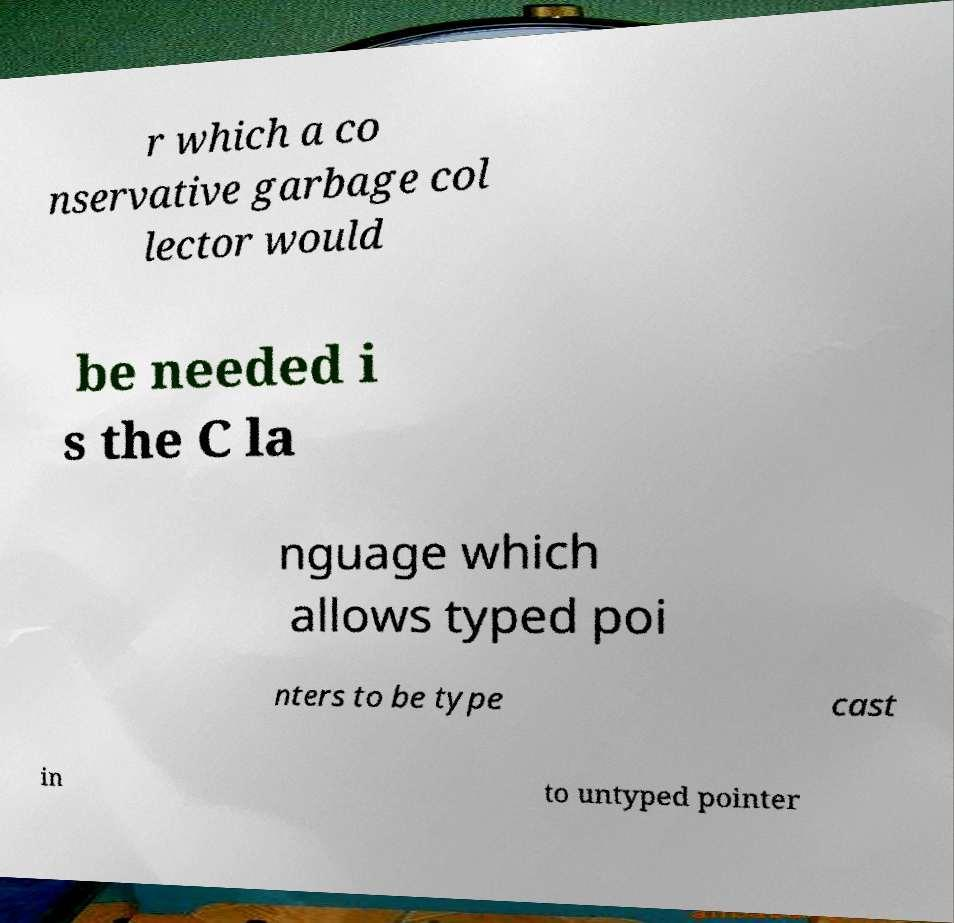Please read and relay the text visible in this image. What does it say? r which a co nservative garbage col lector would be needed i s the C la nguage which allows typed poi nters to be type cast in to untyped pointer 